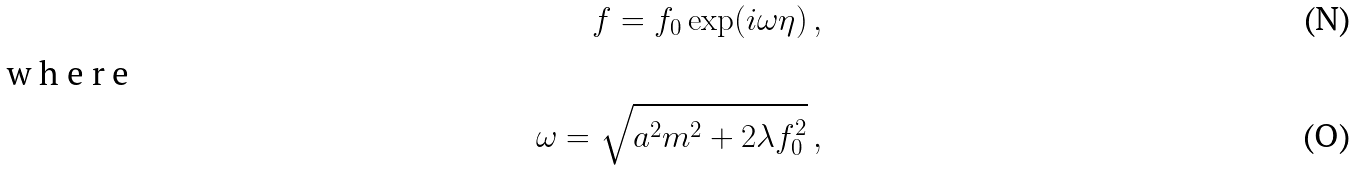Convert formula to latex. <formula><loc_0><loc_0><loc_500><loc_500>f = f _ { 0 } \exp ( i \omega \eta ) \, , \\ \intertext { w h e r e } \omega = \sqrt { a ^ { 2 } m ^ { 2 } + 2 \lambda f _ { 0 } ^ { 2 } } \, ,</formula> 